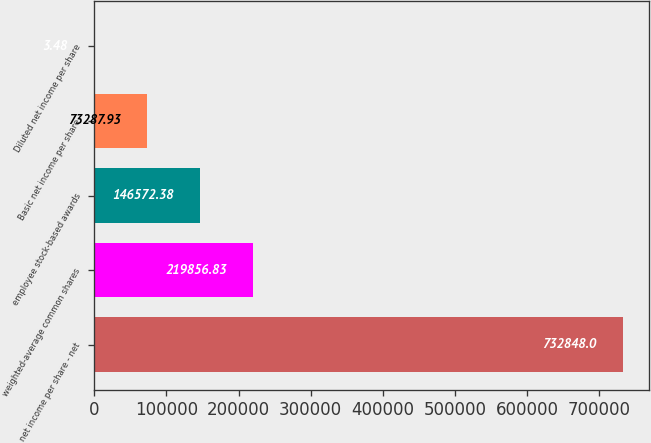Convert chart. <chart><loc_0><loc_0><loc_500><loc_500><bar_chart><fcel>net income per share - net<fcel>weighted-average common shares<fcel>employee stock-based awards<fcel>Basic net income per share<fcel>Diluted net income per share<nl><fcel>732848<fcel>219857<fcel>146572<fcel>73287.9<fcel>3.48<nl></chart> 